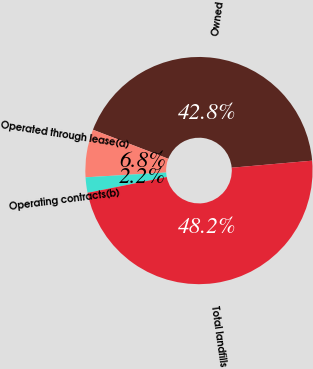<chart> <loc_0><loc_0><loc_500><loc_500><pie_chart><fcel>Owned<fcel>Operated through lease(a)<fcel>Operating contracts(b)<fcel>Total landfills<nl><fcel>42.76%<fcel>6.8%<fcel>2.19%<fcel>48.25%<nl></chart> 